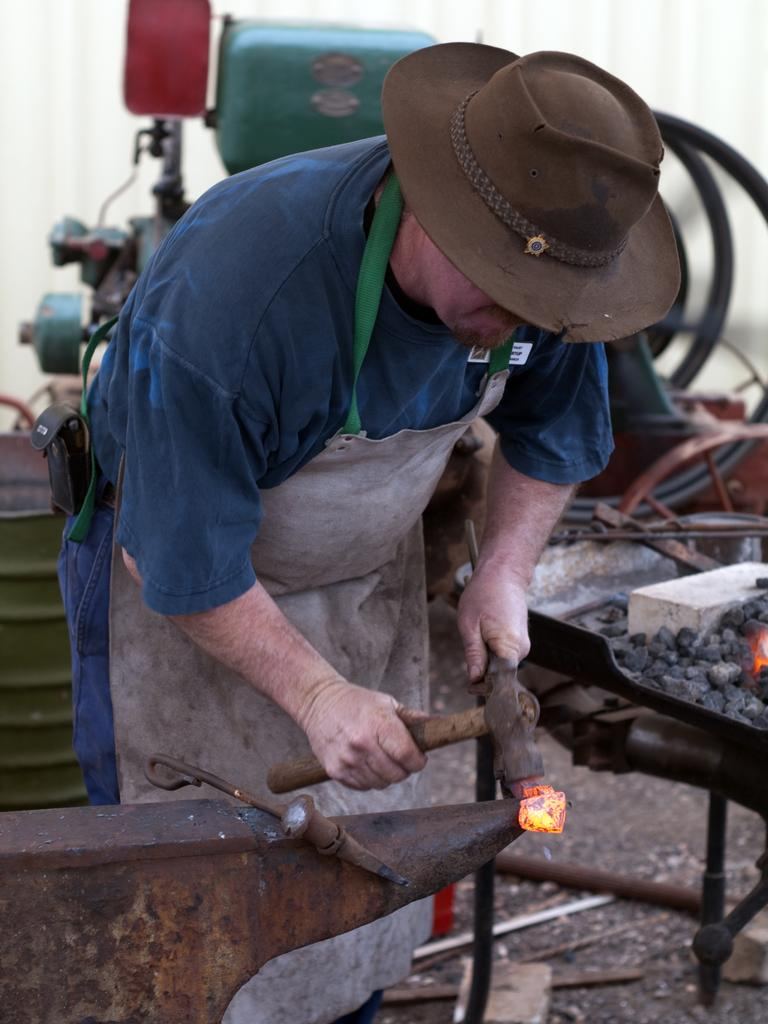What is the main subject of the image? There is a person in the image. What is the person doing in the image? The person is bending in the image. What is the person holding in the image? The person is holding an object in the image. What can be seen in the background of the image? There are charcoals visible in the background of the image. What type of road can be seen in the image? There is no road present in the image. Can you describe the river that is flowing in the background of the image? There is no river present in the image; it features a person bending and holding an object with charcoals visible in the background. 